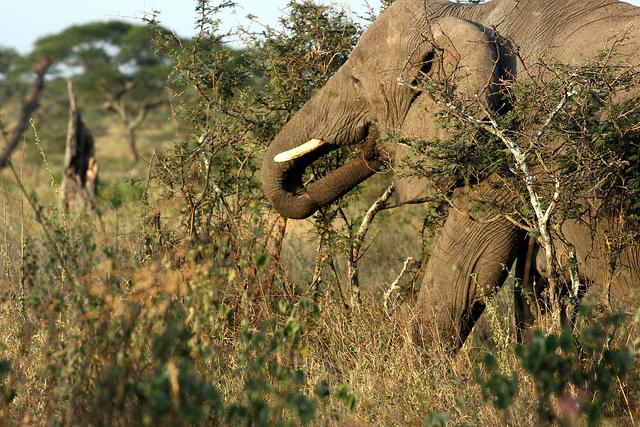What type of animal is closest to the camera?
Concise answer only. Elephant. Is the elephant eating?
Be succinct. Yes. Is there more than one elephant?
Give a very brief answer. No. 